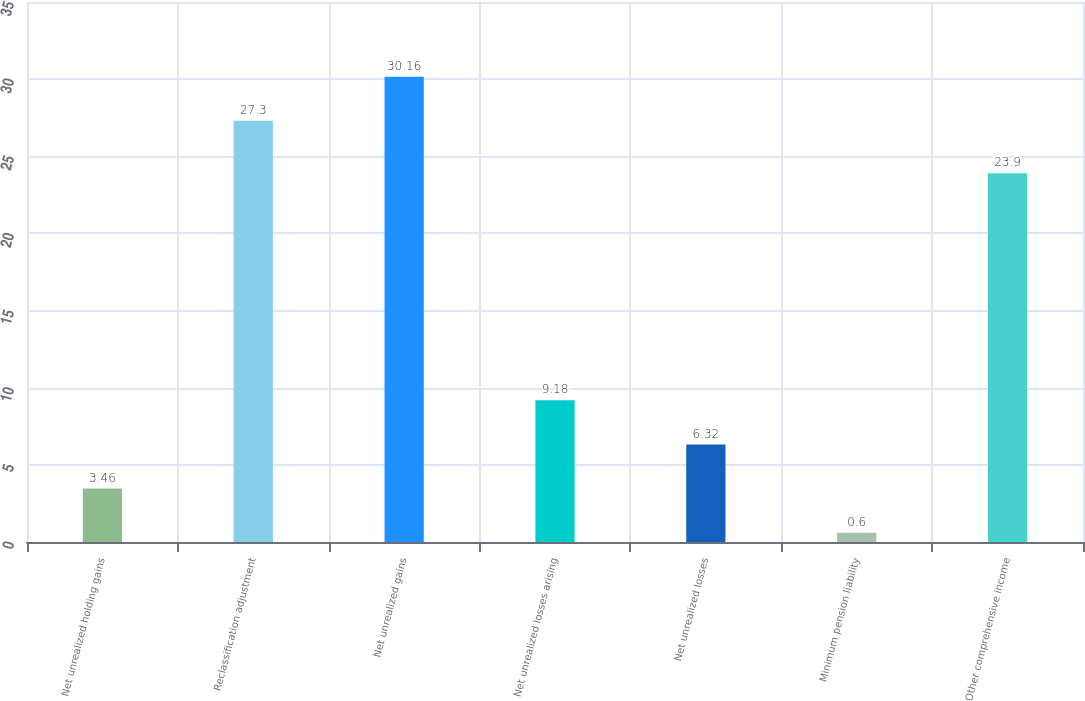<chart> <loc_0><loc_0><loc_500><loc_500><bar_chart><fcel>Net unrealized holding gains<fcel>Reclassification adjustment<fcel>Net unrealized gains<fcel>Net unrealized losses arising<fcel>Net unrealized losses<fcel>Minimum pension liability<fcel>Other comprehensive income<nl><fcel>3.46<fcel>27.3<fcel>30.16<fcel>9.18<fcel>6.32<fcel>0.6<fcel>23.9<nl></chart> 